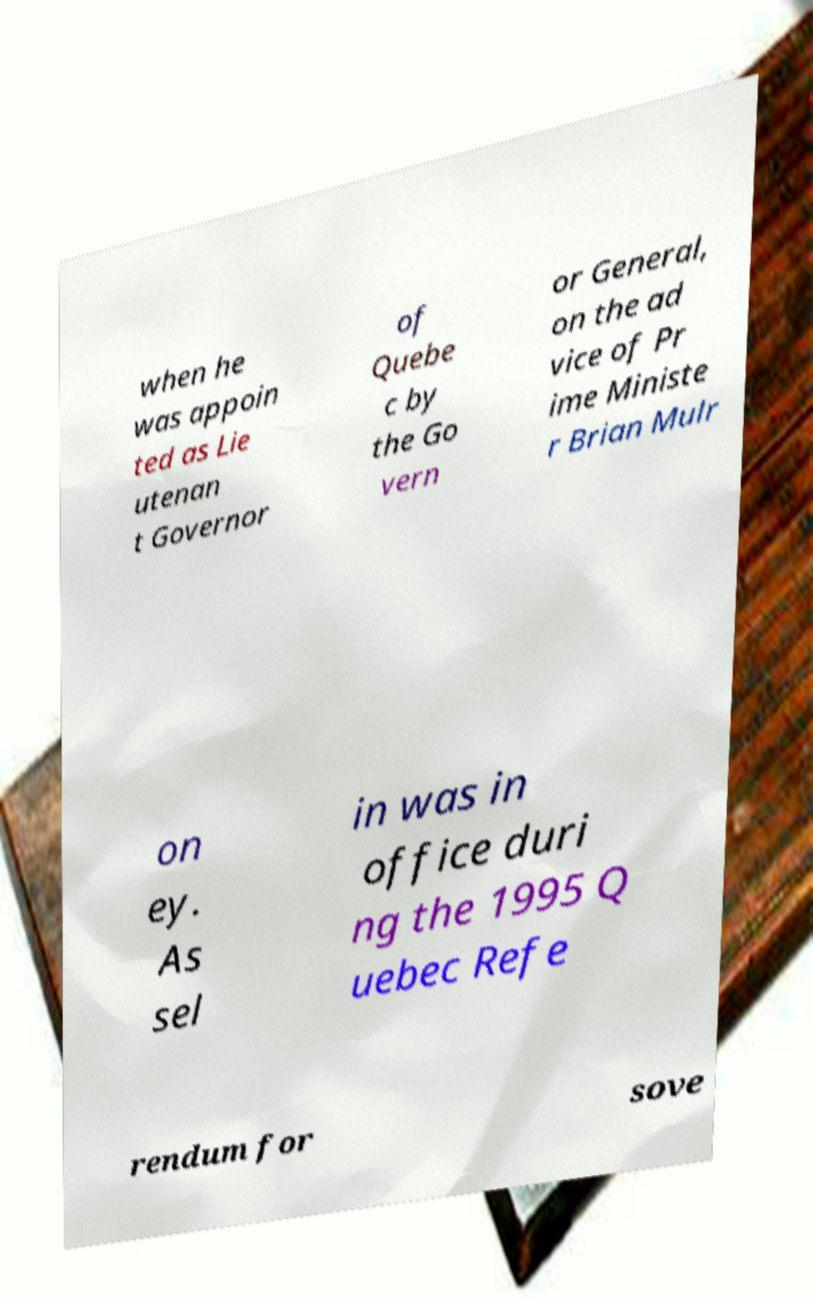Can you accurately transcribe the text from the provided image for me? when he was appoin ted as Lie utenan t Governor of Quebe c by the Go vern or General, on the ad vice of Pr ime Ministe r Brian Mulr on ey. As sel in was in office duri ng the 1995 Q uebec Refe rendum for sove 